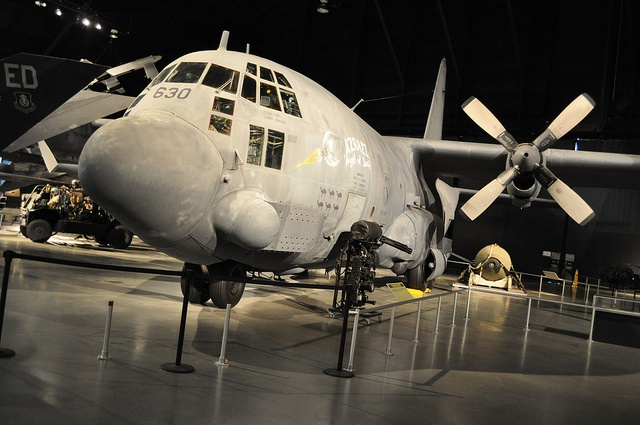Describe the objects in this image and their specific colors. I can see airplane in black, tan, darkgray, and gray tones, car in black, gray, and tan tones, people in black, maroon, and gray tones, and people in black, khaki, tan, and olive tones in this image. 